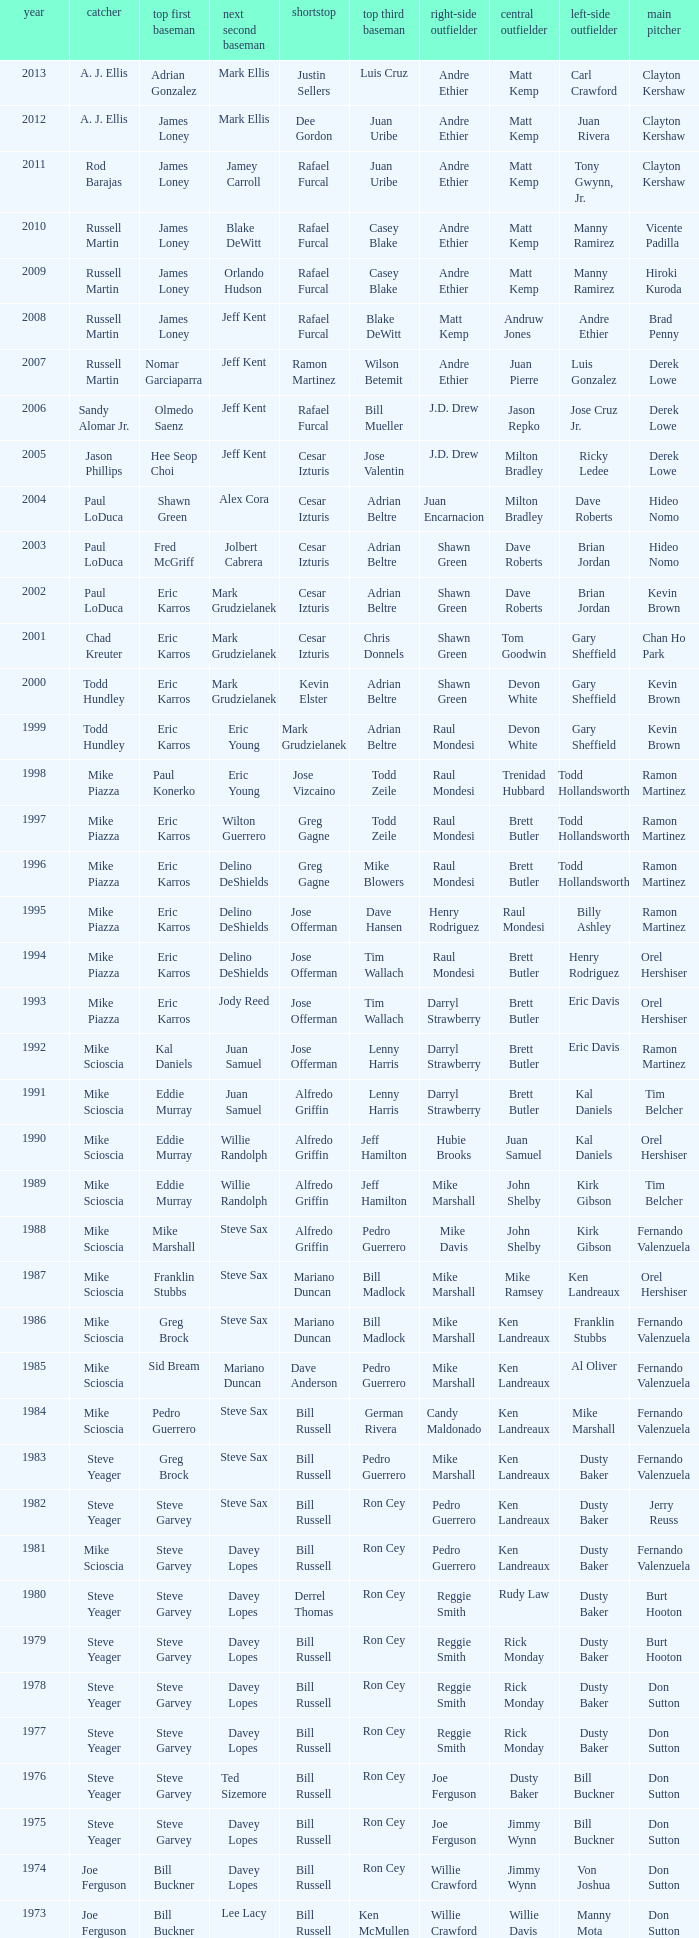Who was the SS when jim lefebvre was at 2nd, willie davis at CF, and don drysdale was the SP. Maury Wills. Could you parse the entire table? {'header': ['year', 'catcher', 'top first baseman', 'next second baseman', 'shortstop', 'top third baseman', 'right-side outfielder', 'central outfielder', 'left-side outfielder', 'main pitcher'], 'rows': [['2013', 'A. J. Ellis', 'Adrian Gonzalez', 'Mark Ellis', 'Justin Sellers', 'Luis Cruz', 'Andre Ethier', 'Matt Kemp', 'Carl Crawford', 'Clayton Kershaw'], ['2012', 'A. J. Ellis', 'James Loney', 'Mark Ellis', 'Dee Gordon', 'Juan Uribe', 'Andre Ethier', 'Matt Kemp', 'Juan Rivera', 'Clayton Kershaw'], ['2011', 'Rod Barajas', 'James Loney', 'Jamey Carroll', 'Rafael Furcal', 'Juan Uribe', 'Andre Ethier', 'Matt Kemp', 'Tony Gwynn, Jr.', 'Clayton Kershaw'], ['2010', 'Russell Martin', 'James Loney', 'Blake DeWitt', 'Rafael Furcal', 'Casey Blake', 'Andre Ethier', 'Matt Kemp', 'Manny Ramirez', 'Vicente Padilla'], ['2009', 'Russell Martin', 'James Loney', 'Orlando Hudson', 'Rafael Furcal', 'Casey Blake', 'Andre Ethier', 'Matt Kemp', 'Manny Ramirez', 'Hiroki Kuroda'], ['2008', 'Russell Martin', 'James Loney', 'Jeff Kent', 'Rafael Furcal', 'Blake DeWitt', 'Matt Kemp', 'Andruw Jones', 'Andre Ethier', 'Brad Penny'], ['2007', 'Russell Martin', 'Nomar Garciaparra', 'Jeff Kent', 'Ramon Martinez', 'Wilson Betemit', 'Andre Ethier', 'Juan Pierre', 'Luis Gonzalez', 'Derek Lowe'], ['2006', 'Sandy Alomar Jr.', 'Olmedo Saenz', 'Jeff Kent', 'Rafael Furcal', 'Bill Mueller', 'J.D. Drew', 'Jason Repko', 'Jose Cruz Jr.', 'Derek Lowe'], ['2005', 'Jason Phillips', 'Hee Seop Choi', 'Jeff Kent', 'Cesar Izturis', 'Jose Valentin', 'J.D. Drew', 'Milton Bradley', 'Ricky Ledee', 'Derek Lowe'], ['2004', 'Paul LoDuca', 'Shawn Green', 'Alex Cora', 'Cesar Izturis', 'Adrian Beltre', 'Juan Encarnacion', 'Milton Bradley', 'Dave Roberts', 'Hideo Nomo'], ['2003', 'Paul LoDuca', 'Fred McGriff', 'Jolbert Cabrera', 'Cesar Izturis', 'Adrian Beltre', 'Shawn Green', 'Dave Roberts', 'Brian Jordan', 'Hideo Nomo'], ['2002', 'Paul LoDuca', 'Eric Karros', 'Mark Grudzielanek', 'Cesar Izturis', 'Adrian Beltre', 'Shawn Green', 'Dave Roberts', 'Brian Jordan', 'Kevin Brown'], ['2001', 'Chad Kreuter', 'Eric Karros', 'Mark Grudzielanek', 'Cesar Izturis', 'Chris Donnels', 'Shawn Green', 'Tom Goodwin', 'Gary Sheffield', 'Chan Ho Park'], ['2000', 'Todd Hundley', 'Eric Karros', 'Mark Grudzielanek', 'Kevin Elster', 'Adrian Beltre', 'Shawn Green', 'Devon White', 'Gary Sheffield', 'Kevin Brown'], ['1999', 'Todd Hundley', 'Eric Karros', 'Eric Young', 'Mark Grudzielanek', 'Adrian Beltre', 'Raul Mondesi', 'Devon White', 'Gary Sheffield', 'Kevin Brown'], ['1998', 'Mike Piazza', 'Paul Konerko', 'Eric Young', 'Jose Vizcaino', 'Todd Zeile', 'Raul Mondesi', 'Trenidad Hubbard', 'Todd Hollandsworth', 'Ramon Martinez'], ['1997', 'Mike Piazza', 'Eric Karros', 'Wilton Guerrero', 'Greg Gagne', 'Todd Zeile', 'Raul Mondesi', 'Brett Butler', 'Todd Hollandsworth', 'Ramon Martinez'], ['1996', 'Mike Piazza', 'Eric Karros', 'Delino DeShields', 'Greg Gagne', 'Mike Blowers', 'Raul Mondesi', 'Brett Butler', 'Todd Hollandsworth', 'Ramon Martinez'], ['1995', 'Mike Piazza', 'Eric Karros', 'Delino DeShields', 'Jose Offerman', 'Dave Hansen', 'Henry Rodriguez', 'Raul Mondesi', 'Billy Ashley', 'Ramon Martinez'], ['1994', 'Mike Piazza', 'Eric Karros', 'Delino DeShields', 'Jose Offerman', 'Tim Wallach', 'Raul Mondesi', 'Brett Butler', 'Henry Rodriguez', 'Orel Hershiser'], ['1993', 'Mike Piazza', 'Eric Karros', 'Jody Reed', 'Jose Offerman', 'Tim Wallach', 'Darryl Strawberry', 'Brett Butler', 'Eric Davis', 'Orel Hershiser'], ['1992', 'Mike Scioscia', 'Kal Daniels', 'Juan Samuel', 'Jose Offerman', 'Lenny Harris', 'Darryl Strawberry', 'Brett Butler', 'Eric Davis', 'Ramon Martinez'], ['1991', 'Mike Scioscia', 'Eddie Murray', 'Juan Samuel', 'Alfredo Griffin', 'Lenny Harris', 'Darryl Strawberry', 'Brett Butler', 'Kal Daniels', 'Tim Belcher'], ['1990', 'Mike Scioscia', 'Eddie Murray', 'Willie Randolph', 'Alfredo Griffin', 'Jeff Hamilton', 'Hubie Brooks', 'Juan Samuel', 'Kal Daniels', 'Orel Hershiser'], ['1989', 'Mike Scioscia', 'Eddie Murray', 'Willie Randolph', 'Alfredo Griffin', 'Jeff Hamilton', 'Mike Marshall', 'John Shelby', 'Kirk Gibson', 'Tim Belcher'], ['1988', 'Mike Scioscia', 'Mike Marshall', 'Steve Sax', 'Alfredo Griffin', 'Pedro Guerrero', 'Mike Davis', 'John Shelby', 'Kirk Gibson', 'Fernando Valenzuela'], ['1987', 'Mike Scioscia', 'Franklin Stubbs', 'Steve Sax', 'Mariano Duncan', 'Bill Madlock', 'Mike Marshall', 'Mike Ramsey', 'Ken Landreaux', 'Orel Hershiser'], ['1986', 'Mike Scioscia', 'Greg Brock', 'Steve Sax', 'Mariano Duncan', 'Bill Madlock', 'Mike Marshall', 'Ken Landreaux', 'Franklin Stubbs', 'Fernando Valenzuela'], ['1985', 'Mike Scioscia', 'Sid Bream', 'Mariano Duncan', 'Dave Anderson', 'Pedro Guerrero', 'Mike Marshall', 'Ken Landreaux', 'Al Oliver', 'Fernando Valenzuela'], ['1984', 'Mike Scioscia', 'Pedro Guerrero', 'Steve Sax', 'Bill Russell', 'German Rivera', 'Candy Maldonado', 'Ken Landreaux', 'Mike Marshall', 'Fernando Valenzuela'], ['1983', 'Steve Yeager', 'Greg Brock', 'Steve Sax', 'Bill Russell', 'Pedro Guerrero', 'Mike Marshall', 'Ken Landreaux', 'Dusty Baker', 'Fernando Valenzuela'], ['1982', 'Steve Yeager', 'Steve Garvey', 'Steve Sax', 'Bill Russell', 'Ron Cey', 'Pedro Guerrero', 'Ken Landreaux', 'Dusty Baker', 'Jerry Reuss'], ['1981', 'Mike Scioscia', 'Steve Garvey', 'Davey Lopes', 'Bill Russell', 'Ron Cey', 'Pedro Guerrero', 'Ken Landreaux', 'Dusty Baker', 'Fernando Valenzuela'], ['1980', 'Steve Yeager', 'Steve Garvey', 'Davey Lopes', 'Derrel Thomas', 'Ron Cey', 'Reggie Smith', 'Rudy Law', 'Dusty Baker', 'Burt Hooton'], ['1979', 'Steve Yeager', 'Steve Garvey', 'Davey Lopes', 'Bill Russell', 'Ron Cey', 'Reggie Smith', 'Rick Monday', 'Dusty Baker', 'Burt Hooton'], ['1978', 'Steve Yeager', 'Steve Garvey', 'Davey Lopes', 'Bill Russell', 'Ron Cey', 'Reggie Smith', 'Rick Monday', 'Dusty Baker', 'Don Sutton'], ['1977', 'Steve Yeager', 'Steve Garvey', 'Davey Lopes', 'Bill Russell', 'Ron Cey', 'Reggie Smith', 'Rick Monday', 'Dusty Baker', 'Don Sutton'], ['1976', 'Steve Yeager', 'Steve Garvey', 'Ted Sizemore', 'Bill Russell', 'Ron Cey', 'Joe Ferguson', 'Dusty Baker', 'Bill Buckner', 'Don Sutton'], ['1975', 'Steve Yeager', 'Steve Garvey', 'Davey Lopes', 'Bill Russell', 'Ron Cey', 'Joe Ferguson', 'Jimmy Wynn', 'Bill Buckner', 'Don Sutton'], ['1974', 'Joe Ferguson', 'Bill Buckner', 'Davey Lopes', 'Bill Russell', 'Ron Cey', 'Willie Crawford', 'Jimmy Wynn', 'Von Joshua', 'Don Sutton'], ['1973', 'Joe Ferguson', 'Bill Buckner', 'Lee Lacy', 'Bill Russell', 'Ken McMullen', 'Willie Crawford', 'Willie Davis', 'Manny Mota', 'Don Sutton'], ['1972', 'Duke Sims', 'Bill Buckner', 'Jim Lefebvre', 'Maury Wills', 'Billy Grabarkewitz', 'Frank Robinson', 'Willie Davis', 'Willie Crawford', 'Don Sutton'], ['1971', 'Duke Sims', 'Wes Parker', 'Bill Russell', 'Maury Wills', 'Steve Garvey', 'Bill Buckner', 'Willie Davis', 'Dick Allen', 'Bill Singer'], ['1970', 'Tom Haller', 'Wes Parker', 'Ted Sizemore', 'Maury Wills', 'Steve Garvey', 'Willie Crawford', 'Willie Davis', 'Bill Buckner', 'Claude Osteen'], ['1969', 'Tom Haller', 'Ron Fairly', 'Jim Lefebvre', 'Ted Sizemore', 'Bill Sudakis', 'Len Gabrielson', 'Willie Crawford', 'Andy Kosco', 'Don Drysdale'], ['1968', 'Tom Haller', 'Wes Parker', 'Paul Popovich', 'Zoilo Versalles', 'Bob Bailey', 'Ron Fairly', 'Willie Davis', 'Al Ferrara', 'Claude Osteen'], ['1967', 'Johnny Roseboro', 'Ron Fairly', 'Ron Hunt', 'Gene Michael', 'Jim Lefebvre', 'Lou Johnson', 'Wes Parker', 'Bob Bailey', 'Bob Miller'], ['1966', 'Johnny Roseboro', 'Wes Parker', 'Nate Oliver', 'Maury Wills', 'Jim Lefebvre', 'Ron Fairly', 'Willie Davis', 'Lou Johnson', 'Claude Osteen'], ['1965', 'Johnny Roseboro', 'Wes Parker', 'Jim Lefebvre', 'Maury Wills', 'John Kennedy', 'Ron Fairly', 'Willie Davis', 'Tommy Davis', 'Don Drysdale'], ['1964', 'Johnny Roseboro', 'Ron Fairly', 'Jim Gilliam', 'Maury Wills', 'Johnny Werhas', 'Frank Howard', 'Willie Davis', 'Tommy Davis', 'Sandy Koufax'], ['1963', 'Johnny Roseboro', 'Bill Skowron', 'Nate Oliver', 'Maury Wills', 'Ken McMullen', 'Ron Fairly', 'Willie Davis', 'Tommy Davis', 'Don Drysdale'], ['1962', 'Johnny Roseboro', 'Ron Fairly', 'Jim Gilliam', 'Maury Wills', 'Daryl Spencer', 'Duke Snider', 'Willie Davis', 'Wally Moon', 'Johnny Podres'], ['1961', 'Johnny Roseboro', 'Norm Larker', 'Charlie Neal', 'Maury Wills', 'Tommy Davis', 'Duke Snider', 'Willie Davis', 'Wally Moon', 'Don Drysdale'], ['1960', 'Johnny Roseboro', 'Gil Hodges', 'Charlie Neal', 'Maury Wills', 'Jim Gilliam', 'Duke Snider', 'Don Demeter', 'Wally Moon', 'Don Drysdale'], ['1959', 'Johnny Roseboro', 'Gil Hodges', 'Charlie Neal', 'Don Zimmer', 'Jim Baxes', 'Ron Fairly', 'Duke Snider', 'Wally Moon', 'Don Drysdale']]} 